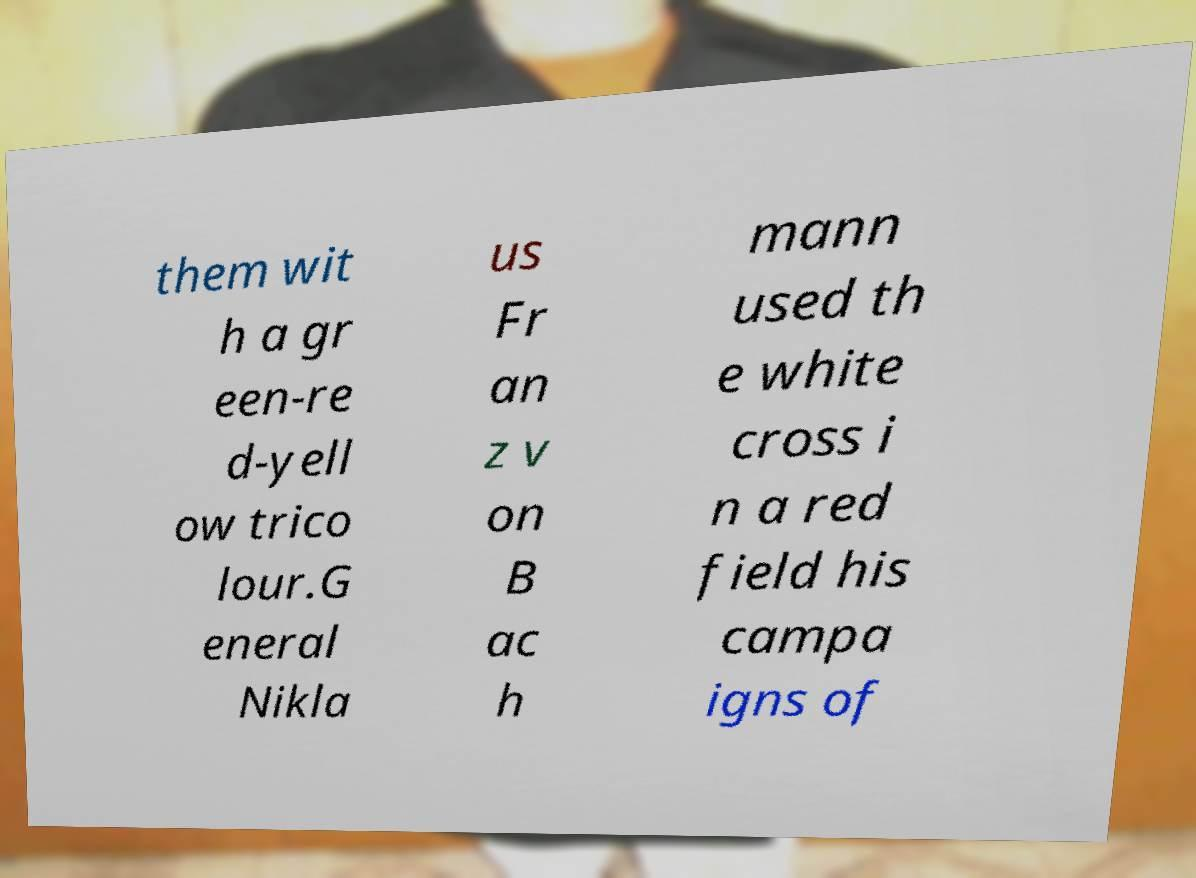There's text embedded in this image that I need extracted. Can you transcribe it verbatim? them wit h a gr een-re d-yell ow trico lour.G eneral Nikla us Fr an z v on B ac h mann used th e white cross i n a red field his campa igns of 